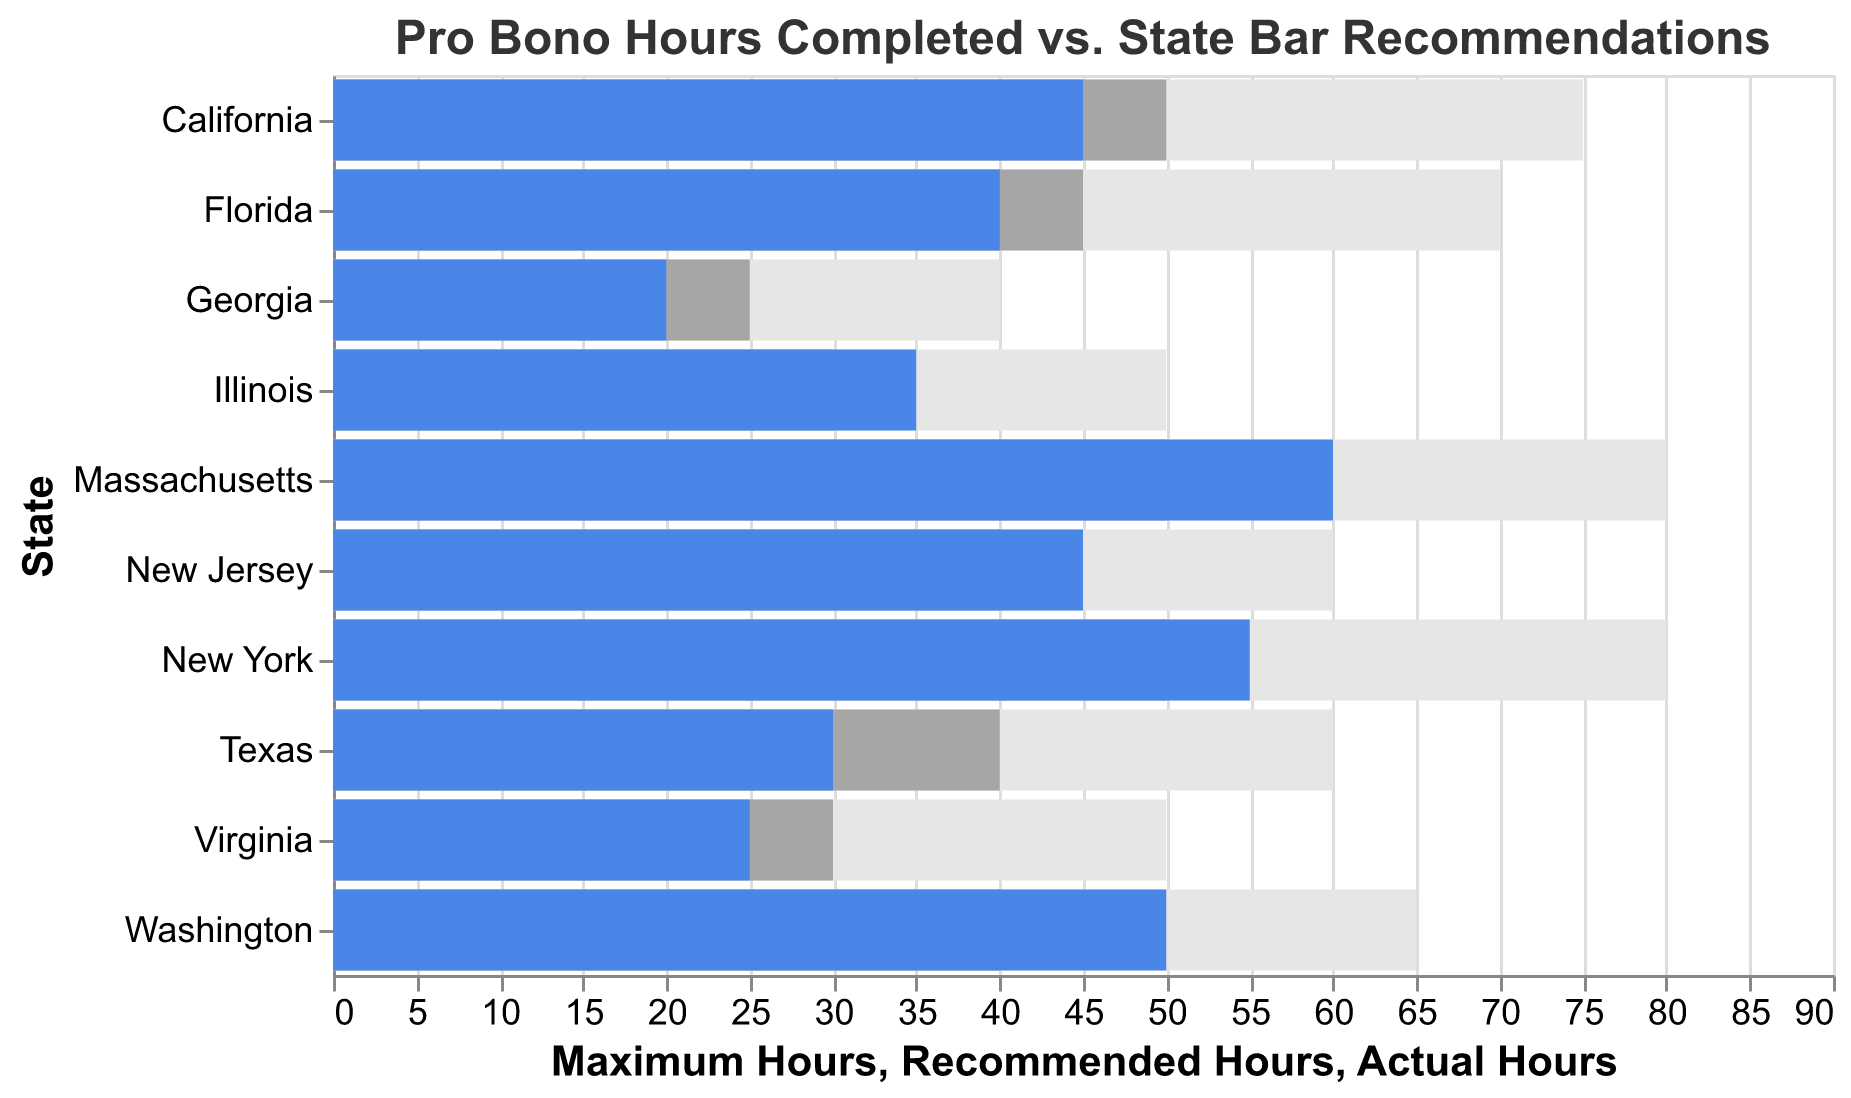Which state has the highest actual hours of pro bono work completed? Massachusetts has the highest actual hours completed with 60 hours as shown by the blue bars compared to other states in the figure.
Answer: Massachusetts Which state met or exceeded the recommended pro bono hours? Massachusetts, New York, and Illinois met or exceeded the recommended hours. This can be seen by comparing the blue bars (actual hours) to the adjacent gray bars (recommended hours).
Answer: Massachusetts, New York, Illinois How many states have actual pro bono hours that are less than their recommended hours? Seven states have actual pro bono hours less than their recommended hours. These states are California, Texas, Florida, Washington, Virginia, Georgia, and New Jersey. This is observed by comparing the blue bars to the gray bars for each state.
Answer: 7 What is the difference between the maximum hours and the actual hours for Texas? The maximum hours for Texas is 60 and the actual hours is 30. The difference is 60 - 30 = 30 hours.
Answer: 30 Which two states have the closest recommended hours? New York and Massachusetts both have the same recommended hours of 50 hours, which is indicated by the gray bars having the same length.
Answer: New York, Massachusetts What is the average actual pro bono hours across all states? The sum of actual pro bono hours is 45 + 55 + 30 + 35 + 40 + 60 + 50 + 25 + 20 + 45 = 405 hours. There are 10 states, so the average is 405 / 10 = 40.5 hours.
Answer: 40.5 Which state has the smallest gap between actual and maximum pro bono hours? Illinois has the smallest gap with 35 actual hours and a maximum of 50, resulting in a gap of 50 - 35 = 15 hours. This is determined by comparing the actual and maximum hours for each state.
Answer: Illinois What is the total amount of pro bono hours recommended by state bars across all states? Summing up the recommended hours for all states gives 50 + 50 + 40 + 30 + 45 + 50 + 40 + 30 + 25 + 40 = 400 hours.
Answer: 400 What is the ratio of actual to maximum pro bono hours for Washington? In Washington, the actual hours are 50 and the maximum hours are 65. The ratio is 50 / 65 ≈ 0.77.
Answer: 0.77 